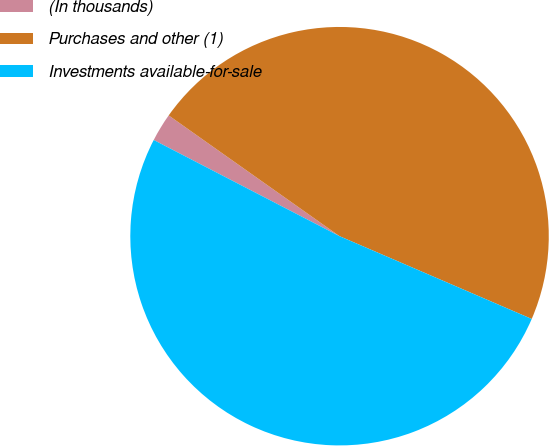<chart> <loc_0><loc_0><loc_500><loc_500><pie_chart><fcel>(In thousands)<fcel>Purchases and other (1)<fcel>Investments available-for-sale<nl><fcel>2.19%<fcel>46.68%<fcel>51.13%<nl></chart> 